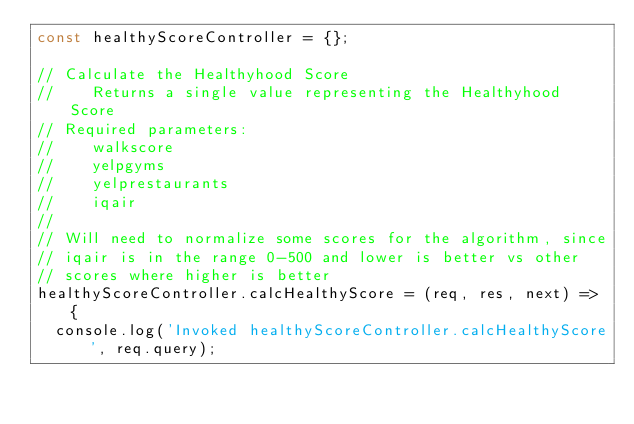<code> <loc_0><loc_0><loc_500><loc_500><_JavaScript_>const healthyScoreController = {};

// Calculate the Healthyhood Score
//    Returns a single value representing the Healthyhood Score
// Required parameters:
//    walkscore
//    yelpgyms
//    yelprestaurants
//    iqair
//
// Will need to normalize some scores for the algorithm, since
// iqair is in the range 0-500 and lower is better vs other
// scores where higher is better
healthyScoreController.calcHealthyScore = (req, res, next) => {
  console.log('Invoked healthyScoreController.calcHealthyScore', req.query);</code> 